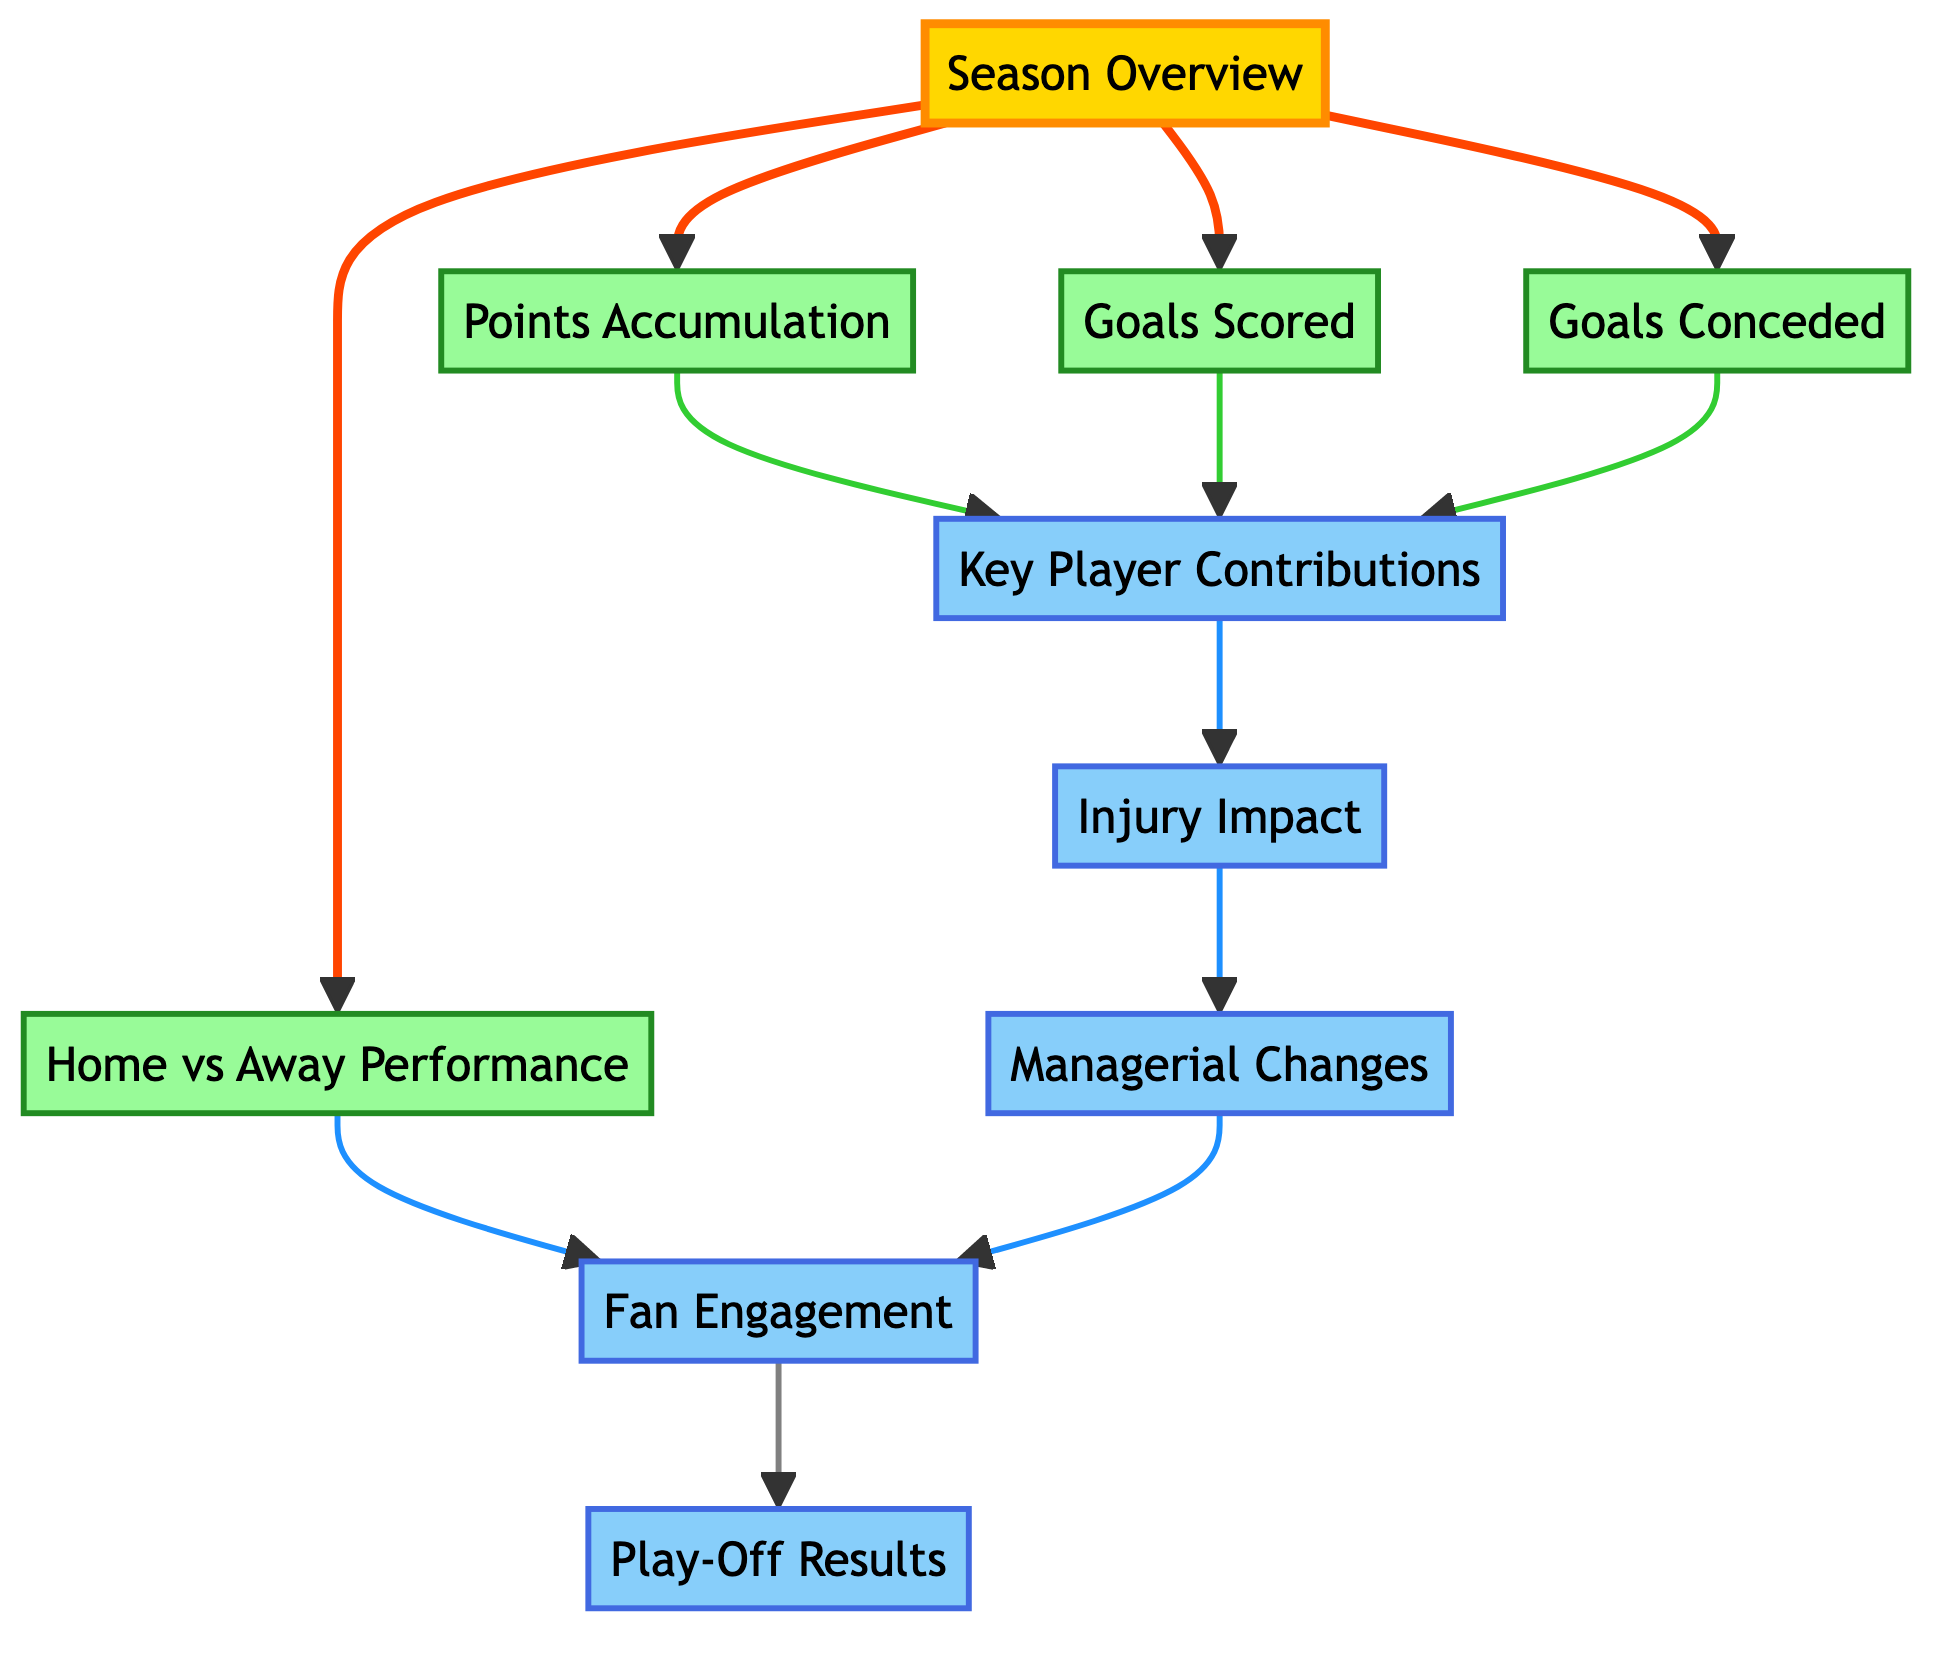What is the starting point of the flowchart? The flowchart begins with the "Season Overview" node, which provides a summary of overall performance for each season and serves as the initial entry point into the analysis.
Answer: Season Overview How many main performance metrics are linked directly to the Season Overview? From the "Season Overview" node, there are four direct links leading to the performance metrics: "Points Accumulation," "Goals Scored," "Goals Conceded," and "Home vs Away Performance," totaling four main metrics.
Answer: Four Which node is impacted by "Key Player Contributions" and "Injury Impact"? Both "Key Player Contributions" and "Injury Impact" influence the "Managerial Changes" node, as they form part of the assessment of overall performance aspects that can affect managerial decisions.
Answer: Managerial Changes What is the relationship between "Fan Engagement" and "Play-Off Results"? "Fan Engagement" directly leads to "Play-Off Results," indicating that the levels of fan support and attendance at matches may impact the outcomes of any play-off matches in the last five seasons.
Answer: Direct connection Which element of the diagram shows how injuries affect a team's performance? The "Injury Impact" element specifically illustrates the effect of player injuries on season performance, highlighting how injuries can influence overall results.
Answer: Injury Impact How many different types of nodes are categorized in the flowchart? The flowchart categorizes nodes into three types: season nodes, performance nodes, and impact nodes, totaling three different categories.
Answer: Three What metric is directly associated with both goals scored and goals conceded? "Key Player Contributions" is directly associated with both "Goals Scored" and "Goals Conceded," indicating that standout players can significantly affect both scoring and conceding goals.
Answer: Key Player Contributions Which node is a result of both managerial changes and injury impact? The node that results from the combination of "Managerial Changes" and "Injury Impact" is "Fan Engagement," showing how managerial decisions and injury effects can affect fan support.
Answer: Fan Engagement What does the Home vs Away Performance node analyze? The "Home vs Away Performance" node analyzes the comparison of Exeter City's performance during home matches relative to away matches across the seasons.
Answer: Comparison of performance 